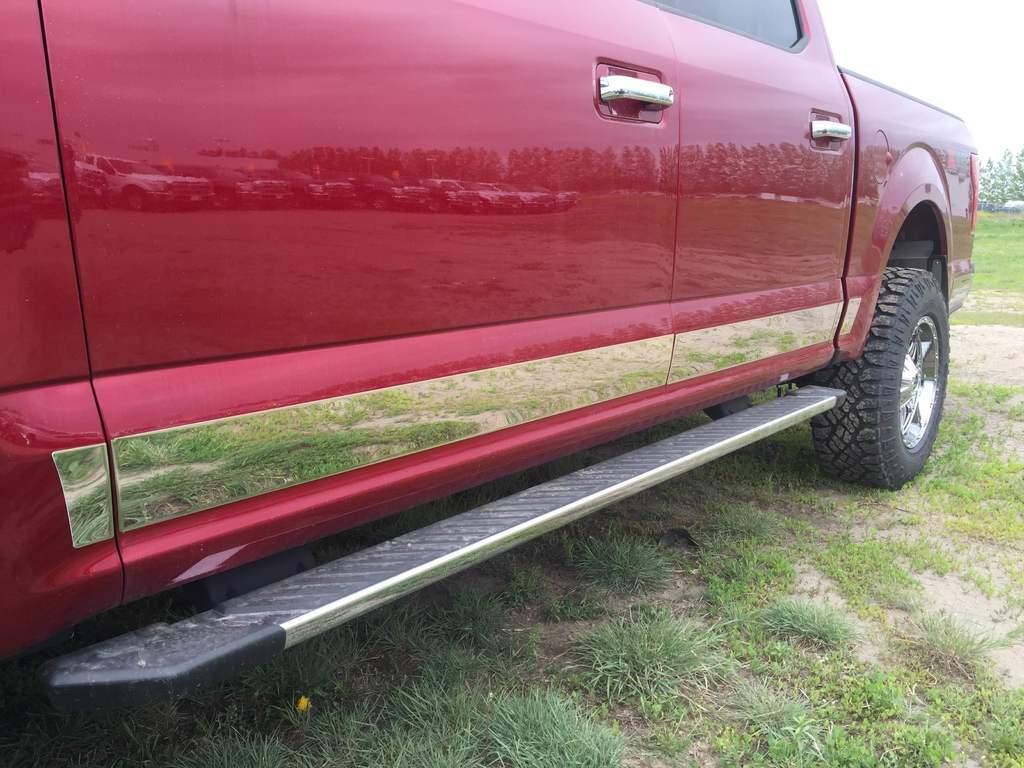Describe this image in one or two sentences. In this image, we can see a car, there is grass on the ground. 